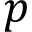<formula> <loc_0><loc_0><loc_500><loc_500>p</formula> 